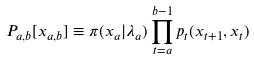<formula> <loc_0><loc_0><loc_500><loc_500>P _ { a , b } [ x _ { a , b } ] \equiv \pi ( x _ { a } | \lambda _ { a } ) \prod _ { t = a } ^ { b - 1 } p _ { t } ( x _ { t + 1 } , x _ { t } )</formula> 